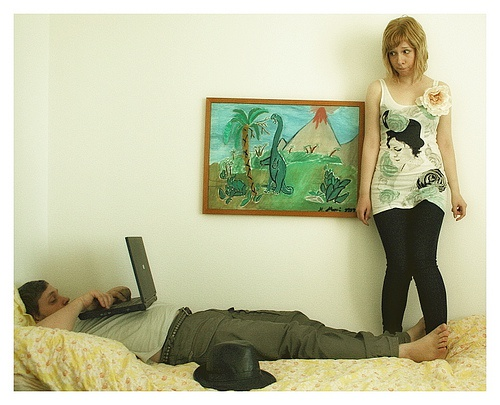Describe the objects in this image and their specific colors. I can see people in white, black, khaki, tan, and beige tones, people in white, darkgreen, olive, and black tones, bed in white, khaki, and tan tones, and laptop in white, darkgreen, black, olive, and beige tones in this image. 